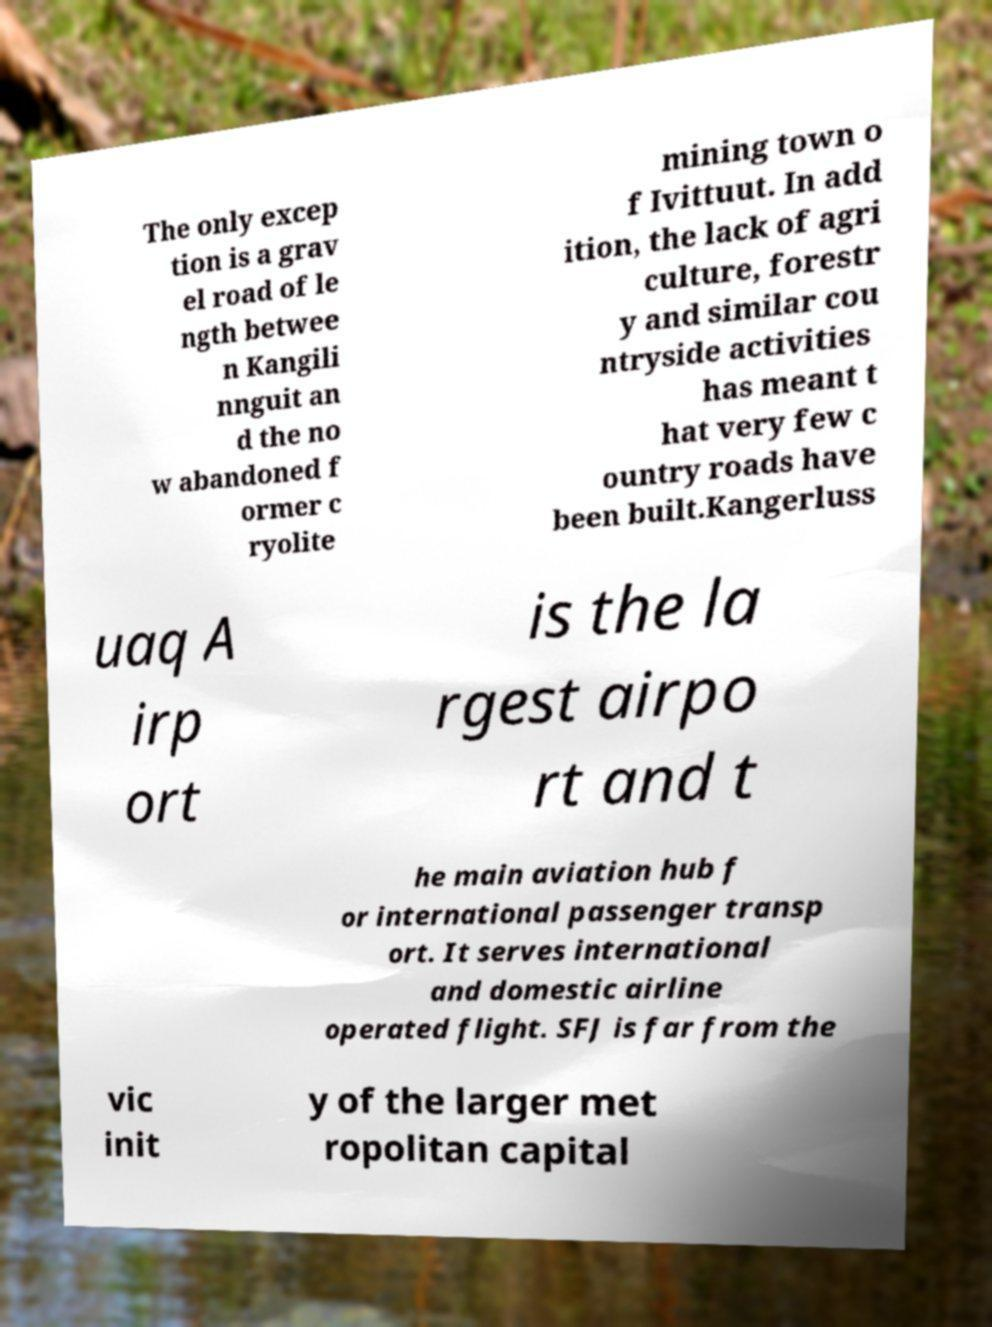For documentation purposes, I need the text within this image transcribed. Could you provide that? The only excep tion is a grav el road of le ngth betwee n Kangili nnguit an d the no w abandoned f ormer c ryolite mining town o f Ivittuut. In add ition, the lack of agri culture, forestr y and similar cou ntryside activities has meant t hat very few c ountry roads have been built.Kangerluss uaq A irp ort is the la rgest airpo rt and t he main aviation hub f or international passenger transp ort. It serves international and domestic airline operated flight. SFJ is far from the vic init y of the larger met ropolitan capital 